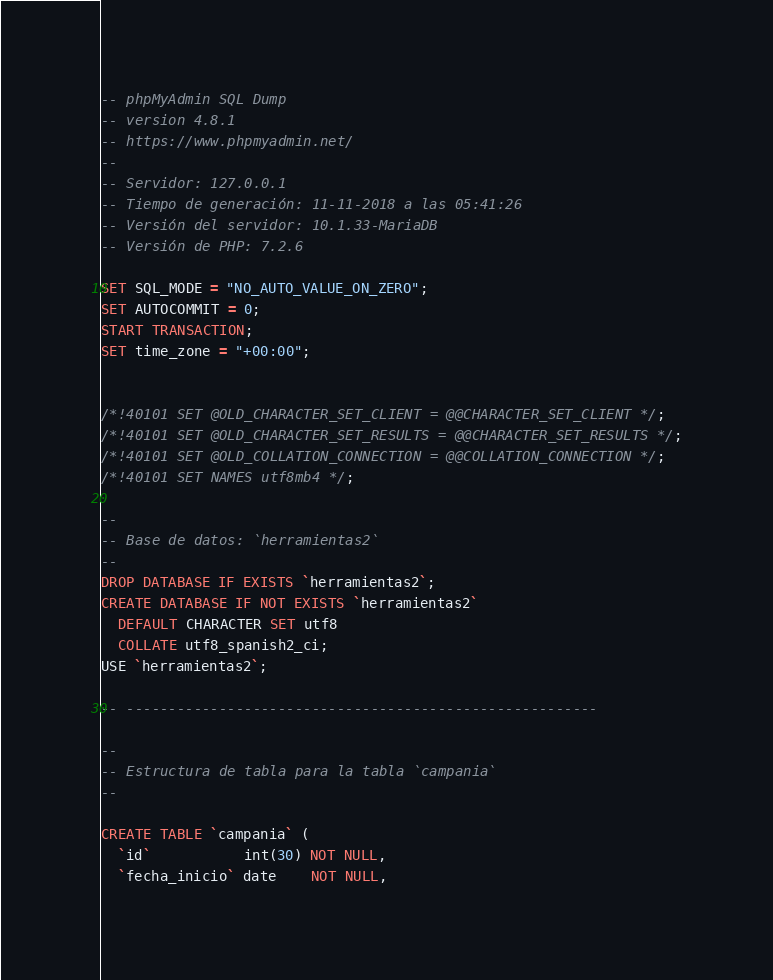Convert code to text. <code><loc_0><loc_0><loc_500><loc_500><_SQL_>-- phpMyAdmin SQL Dump
-- version 4.8.1
-- https://www.phpmyadmin.net/
--
-- Servidor: 127.0.0.1
-- Tiempo de generación: 11-11-2018 a las 05:41:26
-- Versión del servidor: 10.1.33-MariaDB
-- Versión de PHP: 7.2.6

SET SQL_MODE = "NO_AUTO_VALUE_ON_ZERO";
SET AUTOCOMMIT = 0;
START TRANSACTION;
SET time_zone = "+00:00";


/*!40101 SET @OLD_CHARACTER_SET_CLIENT = @@CHARACTER_SET_CLIENT */;
/*!40101 SET @OLD_CHARACTER_SET_RESULTS = @@CHARACTER_SET_RESULTS */;
/*!40101 SET @OLD_COLLATION_CONNECTION = @@COLLATION_CONNECTION */;
/*!40101 SET NAMES utf8mb4 */;

--
-- Base de datos: `herramientas2`
--
DROP DATABASE IF EXISTS `herramientas2`;
CREATE DATABASE IF NOT EXISTS `herramientas2`
  DEFAULT CHARACTER SET utf8
  COLLATE utf8_spanish2_ci;
USE `herramientas2`;

-- --------------------------------------------------------

--
-- Estructura de tabla para la tabla `campania`
--

CREATE TABLE `campania` (
  `id`           int(30) NOT NULL,
  `fecha_inicio` date    NOT NULL,</code> 